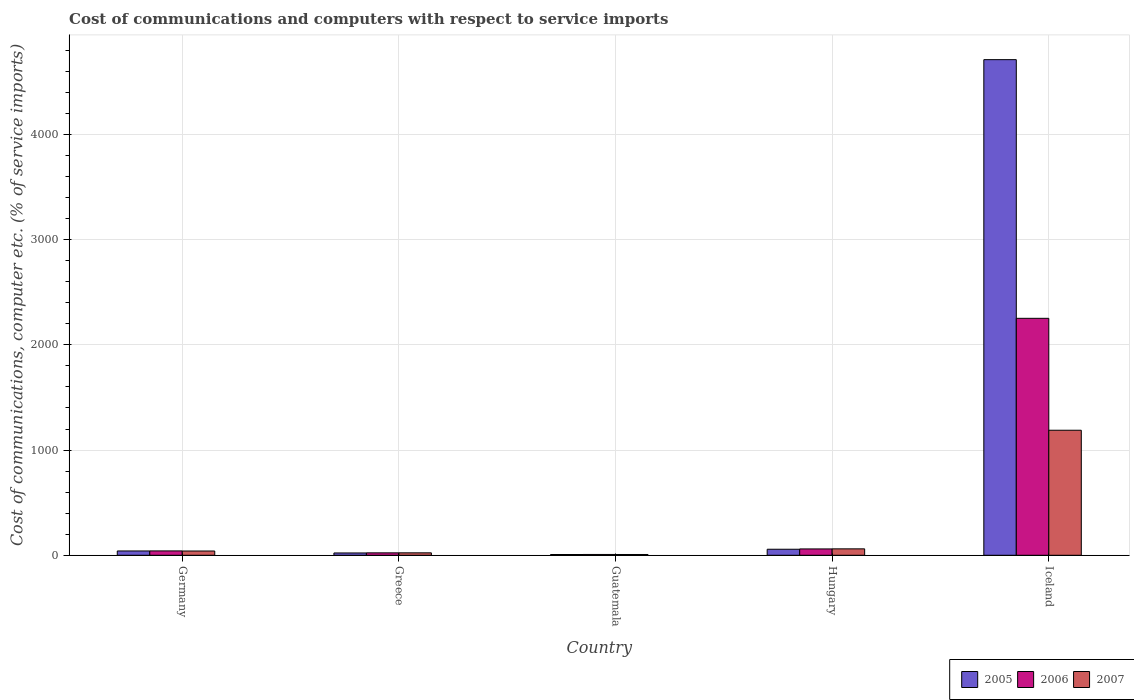Are the number of bars on each tick of the X-axis equal?
Provide a succinct answer. Yes. How many bars are there on the 3rd tick from the right?
Offer a very short reply. 3. What is the label of the 4th group of bars from the left?
Your answer should be compact. Hungary. In how many cases, is the number of bars for a given country not equal to the number of legend labels?
Offer a terse response. 0. What is the cost of communications and computers in 2006 in Germany?
Your answer should be compact. 41.43. Across all countries, what is the maximum cost of communications and computers in 2005?
Your response must be concise. 4710.44. Across all countries, what is the minimum cost of communications and computers in 2006?
Your answer should be compact. 7.74. In which country was the cost of communications and computers in 2006 maximum?
Provide a succinct answer. Iceland. In which country was the cost of communications and computers in 2006 minimum?
Your answer should be very brief. Guatemala. What is the total cost of communications and computers in 2006 in the graph?
Make the answer very short. 2384.53. What is the difference between the cost of communications and computers in 2005 in Hungary and that in Iceland?
Make the answer very short. -4653.18. What is the difference between the cost of communications and computers in 2006 in Greece and the cost of communications and computers in 2005 in Guatemala?
Ensure brevity in your answer.  15.77. What is the average cost of communications and computers in 2006 per country?
Provide a succinct answer. 476.91. What is the difference between the cost of communications and computers of/in 2005 and cost of communications and computers of/in 2007 in Hungary?
Keep it short and to the point. -3.78. What is the ratio of the cost of communications and computers in 2005 in Greece to that in Guatemala?
Your response must be concise. 3.03. Is the cost of communications and computers in 2005 in Greece less than that in Hungary?
Your response must be concise. Yes. Is the difference between the cost of communications and computers in 2005 in Greece and Guatemala greater than the difference between the cost of communications and computers in 2007 in Greece and Guatemala?
Provide a succinct answer. No. What is the difference between the highest and the second highest cost of communications and computers in 2007?
Keep it short and to the point. -1147.67. What is the difference between the highest and the lowest cost of communications and computers in 2007?
Your answer should be compact. 1180.82. In how many countries, is the cost of communications and computers in 2006 greater than the average cost of communications and computers in 2006 taken over all countries?
Your answer should be compact. 1. What does the 3rd bar from the right in Germany represents?
Offer a terse response. 2005. Are all the bars in the graph horizontal?
Your response must be concise. No. Does the graph contain any zero values?
Make the answer very short. No. Where does the legend appear in the graph?
Your answer should be compact. Bottom right. How many legend labels are there?
Your answer should be very brief. 3. What is the title of the graph?
Give a very brief answer. Cost of communications and computers with respect to service imports. Does "1997" appear as one of the legend labels in the graph?
Your answer should be compact. No. What is the label or title of the Y-axis?
Provide a succinct answer. Cost of communications, computer etc. (% of service imports). What is the Cost of communications, computer etc. (% of service imports) of 2005 in Germany?
Provide a short and direct response. 40.98. What is the Cost of communications, computer etc. (% of service imports) in 2006 in Germany?
Your response must be concise. 41.43. What is the Cost of communications, computer etc. (% of service imports) of 2007 in Germany?
Ensure brevity in your answer.  40.6. What is the Cost of communications, computer etc. (% of service imports) of 2005 in Greece?
Keep it short and to the point. 21.97. What is the Cost of communications, computer etc. (% of service imports) in 2006 in Greece?
Offer a terse response. 23.02. What is the Cost of communications, computer etc. (% of service imports) of 2007 in Greece?
Make the answer very short. 23.13. What is the Cost of communications, computer etc. (% of service imports) in 2005 in Guatemala?
Give a very brief answer. 7.24. What is the Cost of communications, computer etc. (% of service imports) of 2006 in Guatemala?
Your response must be concise. 7.74. What is the Cost of communications, computer etc. (% of service imports) in 2007 in Guatemala?
Provide a short and direct response. 7.45. What is the Cost of communications, computer etc. (% of service imports) in 2005 in Hungary?
Make the answer very short. 57.26. What is the Cost of communications, computer etc. (% of service imports) of 2006 in Hungary?
Your response must be concise. 60.31. What is the Cost of communications, computer etc. (% of service imports) of 2007 in Hungary?
Provide a short and direct response. 61.04. What is the Cost of communications, computer etc. (% of service imports) in 2005 in Iceland?
Your answer should be compact. 4710.44. What is the Cost of communications, computer etc. (% of service imports) in 2006 in Iceland?
Provide a succinct answer. 2252.04. What is the Cost of communications, computer etc. (% of service imports) in 2007 in Iceland?
Your answer should be very brief. 1188.27. Across all countries, what is the maximum Cost of communications, computer etc. (% of service imports) in 2005?
Offer a very short reply. 4710.44. Across all countries, what is the maximum Cost of communications, computer etc. (% of service imports) in 2006?
Give a very brief answer. 2252.04. Across all countries, what is the maximum Cost of communications, computer etc. (% of service imports) in 2007?
Keep it short and to the point. 1188.27. Across all countries, what is the minimum Cost of communications, computer etc. (% of service imports) in 2005?
Provide a short and direct response. 7.24. Across all countries, what is the minimum Cost of communications, computer etc. (% of service imports) of 2006?
Provide a short and direct response. 7.74. Across all countries, what is the minimum Cost of communications, computer etc. (% of service imports) of 2007?
Make the answer very short. 7.45. What is the total Cost of communications, computer etc. (% of service imports) of 2005 in the graph?
Offer a terse response. 4837.89. What is the total Cost of communications, computer etc. (% of service imports) of 2006 in the graph?
Give a very brief answer. 2384.53. What is the total Cost of communications, computer etc. (% of service imports) in 2007 in the graph?
Your answer should be very brief. 1320.48. What is the difference between the Cost of communications, computer etc. (% of service imports) in 2005 in Germany and that in Greece?
Provide a succinct answer. 19.02. What is the difference between the Cost of communications, computer etc. (% of service imports) of 2006 in Germany and that in Greece?
Ensure brevity in your answer.  18.41. What is the difference between the Cost of communications, computer etc. (% of service imports) of 2007 in Germany and that in Greece?
Keep it short and to the point. 17.47. What is the difference between the Cost of communications, computer etc. (% of service imports) in 2005 in Germany and that in Guatemala?
Keep it short and to the point. 33.74. What is the difference between the Cost of communications, computer etc. (% of service imports) in 2006 in Germany and that in Guatemala?
Give a very brief answer. 33.69. What is the difference between the Cost of communications, computer etc. (% of service imports) in 2007 in Germany and that in Guatemala?
Give a very brief answer. 33.15. What is the difference between the Cost of communications, computer etc. (% of service imports) in 2005 in Germany and that in Hungary?
Your answer should be very brief. -16.27. What is the difference between the Cost of communications, computer etc. (% of service imports) in 2006 in Germany and that in Hungary?
Your answer should be very brief. -18.88. What is the difference between the Cost of communications, computer etc. (% of service imports) of 2007 in Germany and that in Hungary?
Your answer should be very brief. -20.44. What is the difference between the Cost of communications, computer etc. (% of service imports) in 2005 in Germany and that in Iceland?
Provide a succinct answer. -4669.46. What is the difference between the Cost of communications, computer etc. (% of service imports) in 2006 in Germany and that in Iceland?
Keep it short and to the point. -2210.61. What is the difference between the Cost of communications, computer etc. (% of service imports) in 2007 in Germany and that in Iceland?
Your answer should be very brief. -1147.67. What is the difference between the Cost of communications, computer etc. (% of service imports) of 2005 in Greece and that in Guatemala?
Keep it short and to the point. 14.72. What is the difference between the Cost of communications, computer etc. (% of service imports) in 2006 in Greece and that in Guatemala?
Your response must be concise. 15.28. What is the difference between the Cost of communications, computer etc. (% of service imports) in 2007 in Greece and that in Guatemala?
Offer a very short reply. 15.68. What is the difference between the Cost of communications, computer etc. (% of service imports) in 2005 in Greece and that in Hungary?
Provide a short and direct response. -35.29. What is the difference between the Cost of communications, computer etc. (% of service imports) in 2006 in Greece and that in Hungary?
Offer a terse response. -37.29. What is the difference between the Cost of communications, computer etc. (% of service imports) of 2007 in Greece and that in Hungary?
Keep it short and to the point. -37.91. What is the difference between the Cost of communications, computer etc. (% of service imports) of 2005 in Greece and that in Iceland?
Make the answer very short. -4688.47. What is the difference between the Cost of communications, computer etc. (% of service imports) of 2006 in Greece and that in Iceland?
Make the answer very short. -2229.02. What is the difference between the Cost of communications, computer etc. (% of service imports) of 2007 in Greece and that in Iceland?
Ensure brevity in your answer.  -1165.14. What is the difference between the Cost of communications, computer etc. (% of service imports) in 2005 in Guatemala and that in Hungary?
Keep it short and to the point. -50.01. What is the difference between the Cost of communications, computer etc. (% of service imports) of 2006 in Guatemala and that in Hungary?
Provide a short and direct response. -52.57. What is the difference between the Cost of communications, computer etc. (% of service imports) of 2007 in Guatemala and that in Hungary?
Provide a short and direct response. -53.59. What is the difference between the Cost of communications, computer etc. (% of service imports) of 2005 in Guatemala and that in Iceland?
Keep it short and to the point. -4703.2. What is the difference between the Cost of communications, computer etc. (% of service imports) of 2006 in Guatemala and that in Iceland?
Provide a succinct answer. -2244.3. What is the difference between the Cost of communications, computer etc. (% of service imports) in 2007 in Guatemala and that in Iceland?
Provide a short and direct response. -1180.82. What is the difference between the Cost of communications, computer etc. (% of service imports) of 2005 in Hungary and that in Iceland?
Your answer should be compact. -4653.18. What is the difference between the Cost of communications, computer etc. (% of service imports) of 2006 in Hungary and that in Iceland?
Make the answer very short. -2191.73. What is the difference between the Cost of communications, computer etc. (% of service imports) of 2007 in Hungary and that in Iceland?
Offer a very short reply. -1127.23. What is the difference between the Cost of communications, computer etc. (% of service imports) in 2005 in Germany and the Cost of communications, computer etc. (% of service imports) in 2006 in Greece?
Your answer should be compact. 17.97. What is the difference between the Cost of communications, computer etc. (% of service imports) of 2005 in Germany and the Cost of communications, computer etc. (% of service imports) of 2007 in Greece?
Provide a succinct answer. 17.86. What is the difference between the Cost of communications, computer etc. (% of service imports) in 2006 in Germany and the Cost of communications, computer etc. (% of service imports) in 2007 in Greece?
Provide a succinct answer. 18.3. What is the difference between the Cost of communications, computer etc. (% of service imports) in 2005 in Germany and the Cost of communications, computer etc. (% of service imports) in 2006 in Guatemala?
Your answer should be compact. 33.25. What is the difference between the Cost of communications, computer etc. (% of service imports) of 2005 in Germany and the Cost of communications, computer etc. (% of service imports) of 2007 in Guatemala?
Offer a very short reply. 33.54. What is the difference between the Cost of communications, computer etc. (% of service imports) in 2006 in Germany and the Cost of communications, computer etc. (% of service imports) in 2007 in Guatemala?
Ensure brevity in your answer.  33.98. What is the difference between the Cost of communications, computer etc. (% of service imports) in 2005 in Germany and the Cost of communications, computer etc. (% of service imports) in 2006 in Hungary?
Your answer should be very brief. -19.32. What is the difference between the Cost of communications, computer etc. (% of service imports) of 2005 in Germany and the Cost of communications, computer etc. (% of service imports) of 2007 in Hungary?
Give a very brief answer. -20.05. What is the difference between the Cost of communications, computer etc. (% of service imports) in 2006 in Germany and the Cost of communications, computer etc. (% of service imports) in 2007 in Hungary?
Keep it short and to the point. -19.61. What is the difference between the Cost of communications, computer etc. (% of service imports) of 2005 in Germany and the Cost of communications, computer etc. (% of service imports) of 2006 in Iceland?
Provide a succinct answer. -2211.05. What is the difference between the Cost of communications, computer etc. (% of service imports) of 2005 in Germany and the Cost of communications, computer etc. (% of service imports) of 2007 in Iceland?
Provide a short and direct response. -1147.28. What is the difference between the Cost of communications, computer etc. (% of service imports) of 2006 in Germany and the Cost of communications, computer etc. (% of service imports) of 2007 in Iceland?
Offer a terse response. -1146.84. What is the difference between the Cost of communications, computer etc. (% of service imports) in 2005 in Greece and the Cost of communications, computer etc. (% of service imports) in 2006 in Guatemala?
Provide a succinct answer. 14.23. What is the difference between the Cost of communications, computer etc. (% of service imports) in 2005 in Greece and the Cost of communications, computer etc. (% of service imports) in 2007 in Guatemala?
Provide a succinct answer. 14.52. What is the difference between the Cost of communications, computer etc. (% of service imports) in 2006 in Greece and the Cost of communications, computer etc. (% of service imports) in 2007 in Guatemala?
Your answer should be compact. 15.57. What is the difference between the Cost of communications, computer etc. (% of service imports) of 2005 in Greece and the Cost of communications, computer etc. (% of service imports) of 2006 in Hungary?
Give a very brief answer. -38.34. What is the difference between the Cost of communications, computer etc. (% of service imports) of 2005 in Greece and the Cost of communications, computer etc. (% of service imports) of 2007 in Hungary?
Offer a very short reply. -39.07. What is the difference between the Cost of communications, computer etc. (% of service imports) of 2006 in Greece and the Cost of communications, computer etc. (% of service imports) of 2007 in Hungary?
Keep it short and to the point. -38.02. What is the difference between the Cost of communications, computer etc. (% of service imports) of 2005 in Greece and the Cost of communications, computer etc. (% of service imports) of 2006 in Iceland?
Provide a succinct answer. -2230.07. What is the difference between the Cost of communications, computer etc. (% of service imports) in 2005 in Greece and the Cost of communications, computer etc. (% of service imports) in 2007 in Iceland?
Offer a terse response. -1166.3. What is the difference between the Cost of communications, computer etc. (% of service imports) in 2006 in Greece and the Cost of communications, computer etc. (% of service imports) in 2007 in Iceland?
Keep it short and to the point. -1165.25. What is the difference between the Cost of communications, computer etc. (% of service imports) in 2005 in Guatemala and the Cost of communications, computer etc. (% of service imports) in 2006 in Hungary?
Keep it short and to the point. -53.07. What is the difference between the Cost of communications, computer etc. (% of service imports) of 2005 in Guatemala and the Cost of communications, computer etc. (% of service imports) of 2007 in Hungary?
Provide a short and direct response. -53.79. What is the difference between the Cost of communications, computer etc. (% of service imports) of 2006 in Guatemala and the Cost of communications, computer etc. (% of service imports) of 2007 in Hungary?
Give a very brief answer. -53.3. What is the difference between the Cost of communications, computer etc. (% of service imports) of 2005 in Guatemala and the Cost of communications, computer etc. (% of service imports) of 2006 in Iceland?
Your answer should be compact. -2244.79. What is the difference between the Cost of communications, computer etc. (% of service imports) in 2005 in Guatemala and the Cost of communications, computer etc. (% of service imports) in 2007 in Iceland?
Ensure brevity in your answer.  -1181.02. What is the difference between the Cost of communications, computer etc. (% of service imports) of 2006 in Guatemala and the Cost of communications, computer etc. (% of service imports) of 2007 in Iceland?
Provide a succinct answer. -1180.53. What is the difference between the Cost of communications, computer etc. (% of service imports) of 2005 in Hungary and the Cost of communications, computer etc. (% of service imports) of 2006 in Iceland?
Ensure brevity in your answer.  -2194.78. What is the difference between the Cost of communications, computer etc. (% of service imports) of 2005 in Hungary and the Cost of communications, computer etc. (% of service imports) of 2007 in Iceland?
Give a very brief answer. -1131.01. What is the difference between the Cost of communications, computer etc. (% of service imports) in 2006 in Hungary and the Cost of communications, computer etc. (% of service imports) in 2007 in Iceland?
Ensure brevity in your answer.  -1127.96. What is the average Cost of communications, computer etc. (% of service imports) in 2005 per country?
Provide a succinct answer. 967.58. What is the average Cost of communications, computer etc. (% of service imports) of 2006 per country?
Provide a short and direct response. 476.91. What is the average Cost of communications, computer etc. (% of service imports) of 2007 per country?
Your response must be concise. 264.1. What is the difference between the Cost of communications, computer etc. (% of service imports) of 2005 and Cost of communications, computer etc. (% of service imports) of 2006 in Germany?
Make the answer very short. -0.44. What is the difference between the Cost of communications, computer etc. (% of service imports) of 2005 and Cost of communications, computer etc. (% of service imports) of 2007 in Germany?
Make the answer very short. 0.39. What is the difference between the Cost of communications, computer etc. (% of service imports) in 2006 and Cost of communications, computer etc. (% of service imports) in 2007 in Germany?
Your answer should be compact. 0.83. What is the difference between the Cost of communications, computer etc. (% of service imports) of 2005 and Cost of communications, computer etc. (% of service imports) of 2006 in Greece?
Provide a short and direct response. -1.05. What is the difference between the Cost of communications, computer etc. (% of service imports) in 2005 and Cost of communications, computer etc. (% of service imports) in 2007 in Greece?
Ensure brevity in your answer.  -1.16. What is the difference between the Cost of communications, computer etc. (% of service imports) in 2006 and Cost of communications, computer etc. (% of service imports) in 2007 in Greece?
Keep it short and to the point. -0.11. What is the difference between the Cost of communications, computer etc. (% of service imports) in 2005 and Cost of communications, computer etc. (% of service imports) in 2006 in Guatemala?
Your answer should be compact. -0.49. What is the difference between the Cost of communications, computer etc. (% of service imports) of 2005 and Cost of communications, computer etc. (% of service imports) of 2007 in Guatemala?
Give a very brief answer. -0.2. What is the difference between the Cost of communications, computer etc. (% of service imports) in 2006 and Cost of communications, computer etc. (% of service imports) in 2007 in Guatemala?
Make the answer very short. 0.29. What is the difference between the Cost of communications, computer etc. (% of service imports) of 2005 and Cost of communications, computer etc. (% of service imports) of 2006 in Hungary?
Make the answer very short. -3.05. What is the difference between the Cost of communications, computer etc. (% of service imports) in 2005 and Cost of communications, computer etc. (% of service imports) in 2007 in Hungary?
Your response must be concise. -3.78. What is the difference between the Cost of communications, computer etc. (% of service imports) of 2006 and Cost of communications, computer etc. (% of service imports) of 2007 in Hungary?
Provide a succinct answer. -0.73. What is the difference between the Cost of communications, computer etc. (% of service imports) of 2005 and Cost of communications, computer etc. (% of service imports) of 2006 in Iceland?
Make the answer very short. 2458.4. What is the difference between the Cost of communications, computer etc. (% of service imports) in 2005 and Cost of communications, computer etc. (% of service imports) in 2007 in Iceland?
Your answer should be very brief. 3522.17. What is the difference between the Cost of communications, computer etc. (% of service imports) of 2006 and Cost of communications, computer etc. (% of service imports) of 2007 in Iceland?
Give a very brief answer. 1063.77. What is the ratio of the Cost of communications, computer etc. (% of service imports) of 2005 in Germany to that in Greece?
Make the answer very short. 1.87. What is the ratio of the Cost of communications, computer etc. (% of service imports) of 2006 in Germany to that in Greece?
Provide a short and direct response. 1.8. What is the ratio of the Cost of communications, computer etc. (% of service imports) in 2007 in Germany to that in Greece?
Provide a short and direct response. 1.76. What is the ratio of the Cost of communications, computer etc. (% of service imports) of 2005 in Germany to that in Guatemala?
Ensure brevity in your answer.  5.66. What is the ratio of the Cost of communications, computer etc. (% of service imports) in 2006 in Germany to that in Guatemala?
Keep it short and to the point. 5.35. What is the ratio of the Cost of communications, computer etc. (% of service imports) in 2007 in Germany to that in Guatemala?
Provide a succinct answer. 5.45. What is the ratio of the Cost of communications, computer etc. (% of service imports) of 2005 in Germany to that in Hungary?
Offer a very short reply. 0.72. What is the ratio of the Cost of communications, computer etc. (% of service imports) in 2006 in Germany to that in Hungary?
Keep it short and to the point. 0.69. What is the ratio of the Cost of communications, computer etc. (% of service imports) in 2007 in Germany to that in Hungary?
Keep it short and to the point. 0.67. What is the ratio of the Cost of communications, computer etc. (% of service imports) in 2005 in Germany to that in Iceland?
Offer a terse response. 0.01. What is the ratio of the Cost of communications, computer etc. (% of service imports) in 2006 in Germany to that in Iceland?
Offer a terse response. 0.02. What is the ratio of the Cost of communications, computer etc. (% of service imports) in 2007 in Germany to that in Iceland?
Provide a succinct answer. 0.03. What is the ratio of the Cost of communications, computer etc. (% of service imports) of 2005 in Greece to that in Guatemala?
Give a very brief answer. 3.03. What is the ratio of the Cost of communications, computer etc. (% of service imports) in 2006 in Greece to that in Guatemala?
Offer a terse response. 2.97. What is the ratio of the Cost of communications, computer etc. (% of service imports) in 2007 in Greece to that in Guatemala?
Ensure brevity in your answer.  3.11. What is the ratio of the Cost of communications, computer etc. (% of service imports) of 2005 in Greece to that in Hungary?
Your answer should be very brief. 0.38. What is the ratio of the Cost of communications, computer etc. (% of service imports) in 2006 in Greece to that in Hungary?
Offer a very short reply. 0.38. What is the ratio of the Cost of communications, computer etc. (% of service imports) of 2007 in Greece to that in Hungary?
Your answer should be compact. 0.38. What is the ratio of the Cost of communications, computer etc. (% of service imports) in 2005 in Greece to that in Iceland?
Make the answer very short. 0. What is the ratio of the Cost of communications, computer etc. (% of service imports) of 2006 in Greece to that in Iceland?
Provide a short and direct response. 0.01. What is the ratio of the Cost of communications, computer etc. (% of service imports) of 2007 in Greece to that in Iceland?
Your answer should be compact. 0.02. What is the ratio of the Cost of communications, computer etc. (% of service imports) in 2005 in Guatemala to that in Hungary?
Ensure brevity in your answer.  0.13. What is the ratio of the Cost of communications, computer etc. (% of service imports) in 2006 in Guatemala to that in Hungary?
Keep it short and to the point. 0.13. What is the ratio of the Cost of communications, computer etc. (% of service imports) in 2007 in Guatemala to that in Hungary?
Your answer should be very brief. 0.12. What is the ratio of the Cost of communications, computer etc. (% of service imports) in 2005 in Guatemala to that in Iceland?
Offer a very short reply. 0. What is the ratio of the Cost of communications, computer etc. (% of service imports) in 2006 in Guatemala to that in Iceland?
Provide a succinct answer. 0. What is the ratio of the Cost of communications, computer etc. (% of service imports) of 2007 in Guatemala to that in Iceland?
Your response must be concise. 0.01. What is the ratio of the Cost of communications, computer etc. (% of service imports) in 2005 in Hungary to that in Iceland?
Provide a succinct answer. 0.01. What is the ratio of the Cost of communications, computer etc. (% of service imports) of 2006 in Hungary to that in Iceland?
Provide a succinct answer. 0.03. What is the ratio of the Cost of communications, computer etc. (% of service imports) of 2007 in Hungary to that in Iceland?
Provide a short and direct response. 0.05. What is the difference between the highest and the second highest Cost of communications, computer etc. (% of service imports) in 2005?
Your response must be concise. 4653.18. What is the difference between the highest and the second highest Cost of communications, computer etc. (% of service imports) in 2006?
Offer a very short reply. 2191.73. What is the difference between the highest and the second highest Cost of communications, computer etc. (% of service imports) of 2007?
Keep it short and to the point. 1127.23. What is the difference between the highest and the lowest Cost of communications, computer etc. (% of service imports) in 2005?
Your answer should be very brief. 4703.2. What is the difference between the highest and the lowest Cost of communications, computer etc. (% of service imports) of 2006?
Your answer should be compact. 2244.3. What is the difference between the highest and the lowest Cost of communications, computer etc. (% of service imports) of 2007?
Offer a very short reply. 1180.82. 